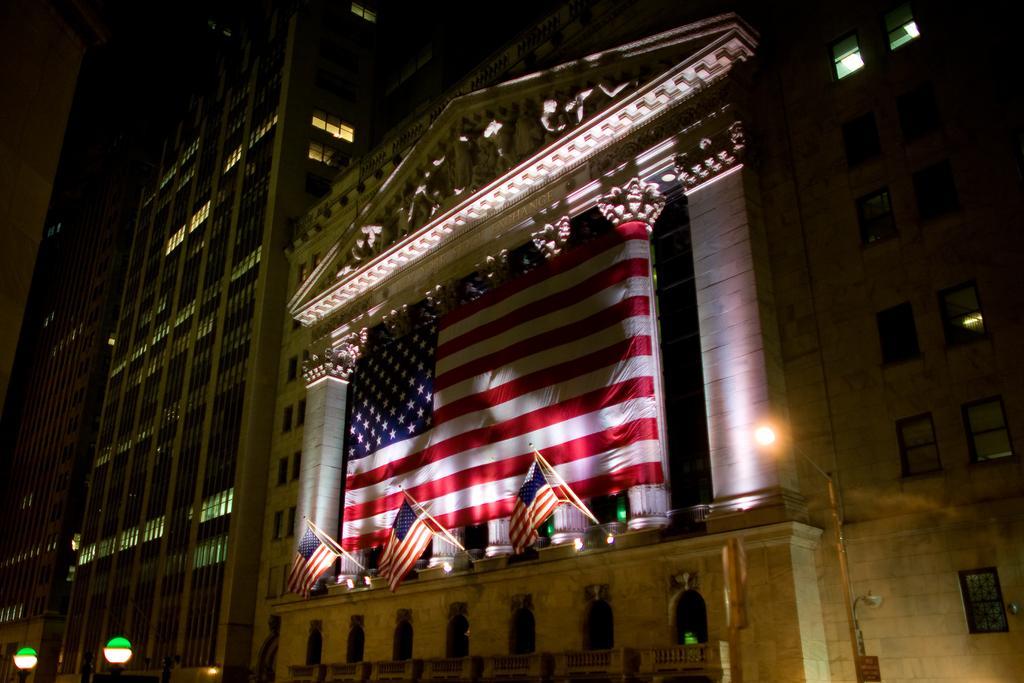Please provide a concise description of this image. This image is taken outdoors. In this image there are a few buildings with walls, windows, doors, railings, balconies and pillars. There are a few carvings on the walls. There are a few lights. There is a big flag and there are three flags. 